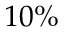Convert formula to latex. <formula><loc_0><loc_0><loc_500><loc_500>1 0 \%</formula> 